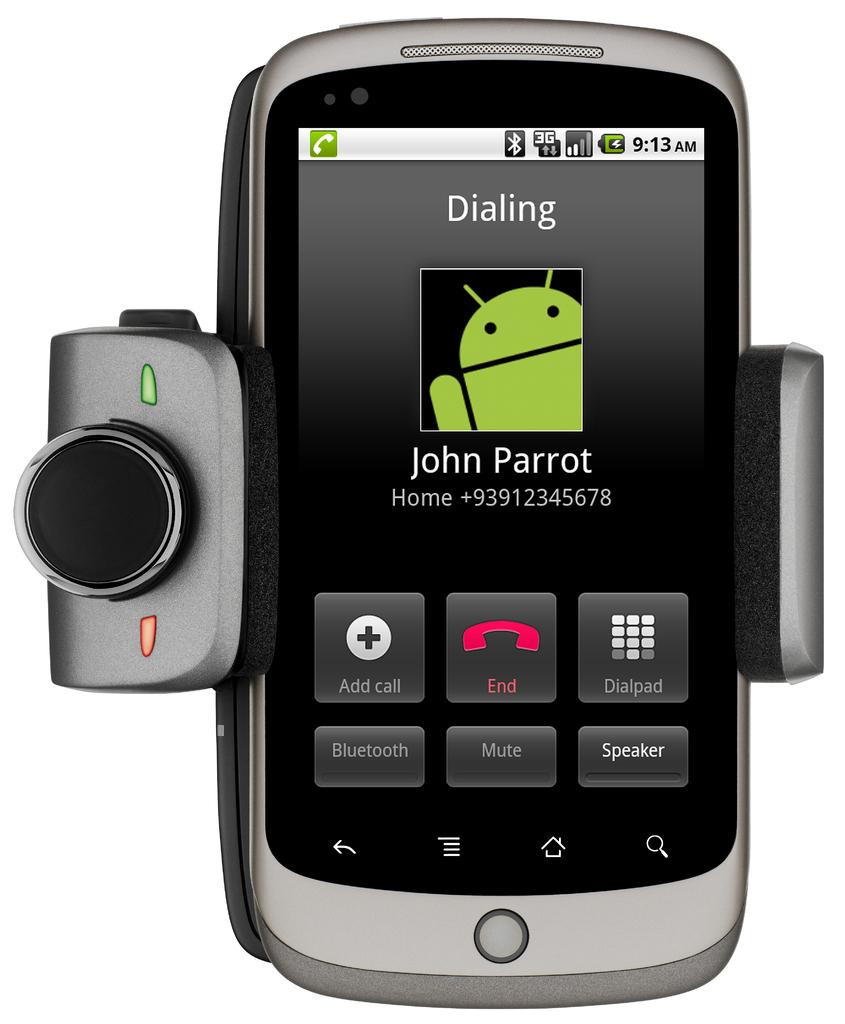<image>
Offer a succinct explanation of the picture presented. A silver phone with a camera attachment that is dialing John Parrot. 